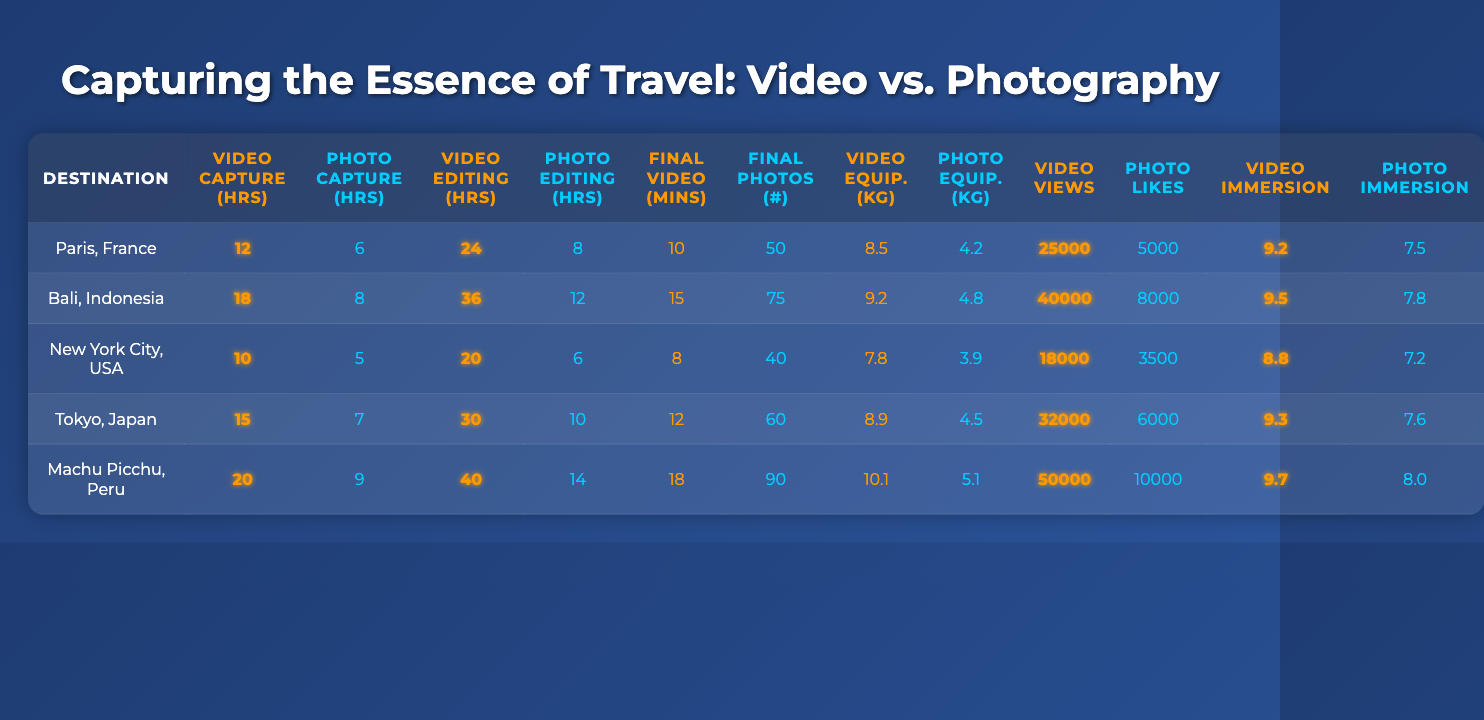What is the total time spent on video capture for all destinations? To find the total time spent on video capture, sum the video capture hours for each destination: 12 + 18 + 10 + 15 + 20 = 75.
Answer: 75 What destination requires the most video editing time? The video editing times are: 24, 36, 20, 30, and 40 hours. The highest value is 40 hours, which corresponds to Machu Picchu, Peru.
Answer: Machu Picchu, Peru What is the difference in video capture time between Tokyo and Bali? Tokyo's video capture time is 15 hours, while Bali's is 18 hours. The difference is 18 - 15 = 3 hours.
Answer: 3 hours Which destination has the highest immersive experience rating for video? The immersive experience ratings for video are: 9.2, 9.5, 8.8, 9.3, and 9.7. The highest rating is 9.7 for Machu Picchu, Peru.
Answer: Machu Picchu, Peru On average, how much time is spent on photo editing across all destinations? To calculate the average time for photo editing, sum the editing times: 8 + 12 + 6 + 10 + 14 = 50 hours. Divide by the number of destinations (5): 50 / 5 = 10 hours.
Answer: 10 hours Is the weight of video equipment heavier than photo equipment for all destinations? Comparing weights: 8.5 vs 4.2, 9.2 vs 4.8, 7.8 vs 3.9, 8.9 vs 4.5, 10.1 vs 5.1, the video equipment is always heavier in each case.
Answer: Yes What is the average number of final photos across all destinations? Summing the number of final photos: 50 + 75 + 40 + 60 + 90 = 315. Then divide by the number of destinations (5): 315 / 5 = 63.
Answer: 63 Which destination had the highest video views and what was the number? The video views are: 25000, 40000, 18000, 32000, and 50000. The highest is 50000 for Machu Picchu, Peru.
Answer: Machu Picchu, Peru; 50000 What is the total weight difference between video equipment and photo equipment for Bali? The weights for Bali are 9.2 kg for video and 4.8 kg for photo. The difference is 9.2 - 4.8 = 4.4 kg.
Answer: 4.4 kg Which type of content shows a higher engagement when comparing views and likes? Looking at views (video) and likes (photo), the highest views are 50000 while the highest likes are 10000 for photos. Since 50000 > 10000, video has higher engagement.
Answer: Video 